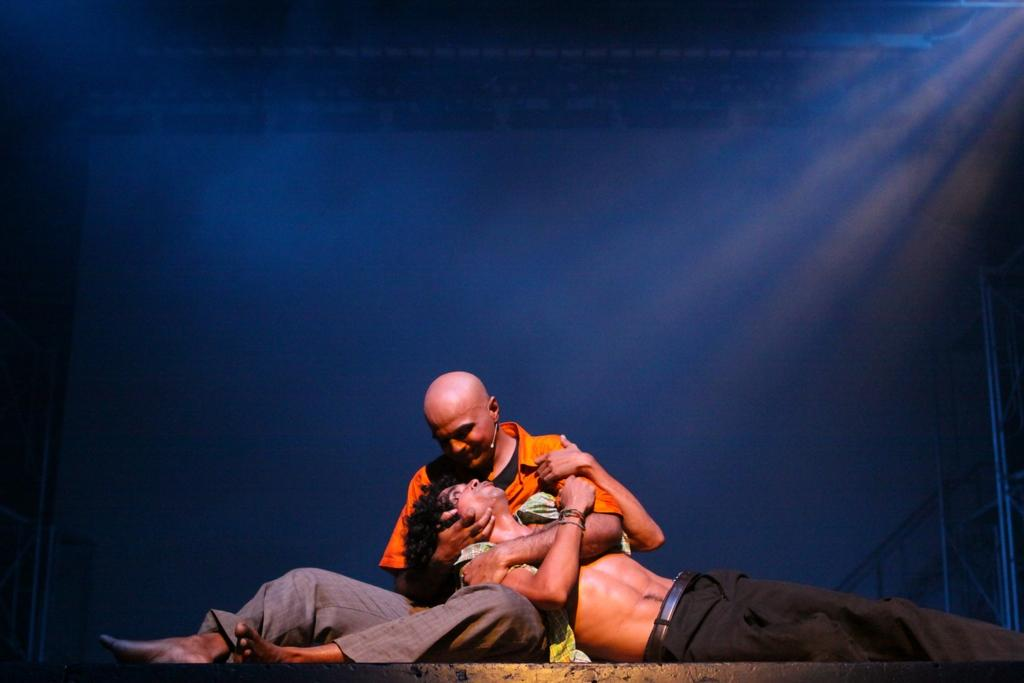How many people are in the image? There are two men in the image. What is one man doing to the other man in the image? One man is lying on the hands of the other man. What colors are used in the background of the image? The background of the image is black and blue. What type of brain activity can be observed in the image? There is no brain present in the image, so it is not possible to observe any brain activity. 